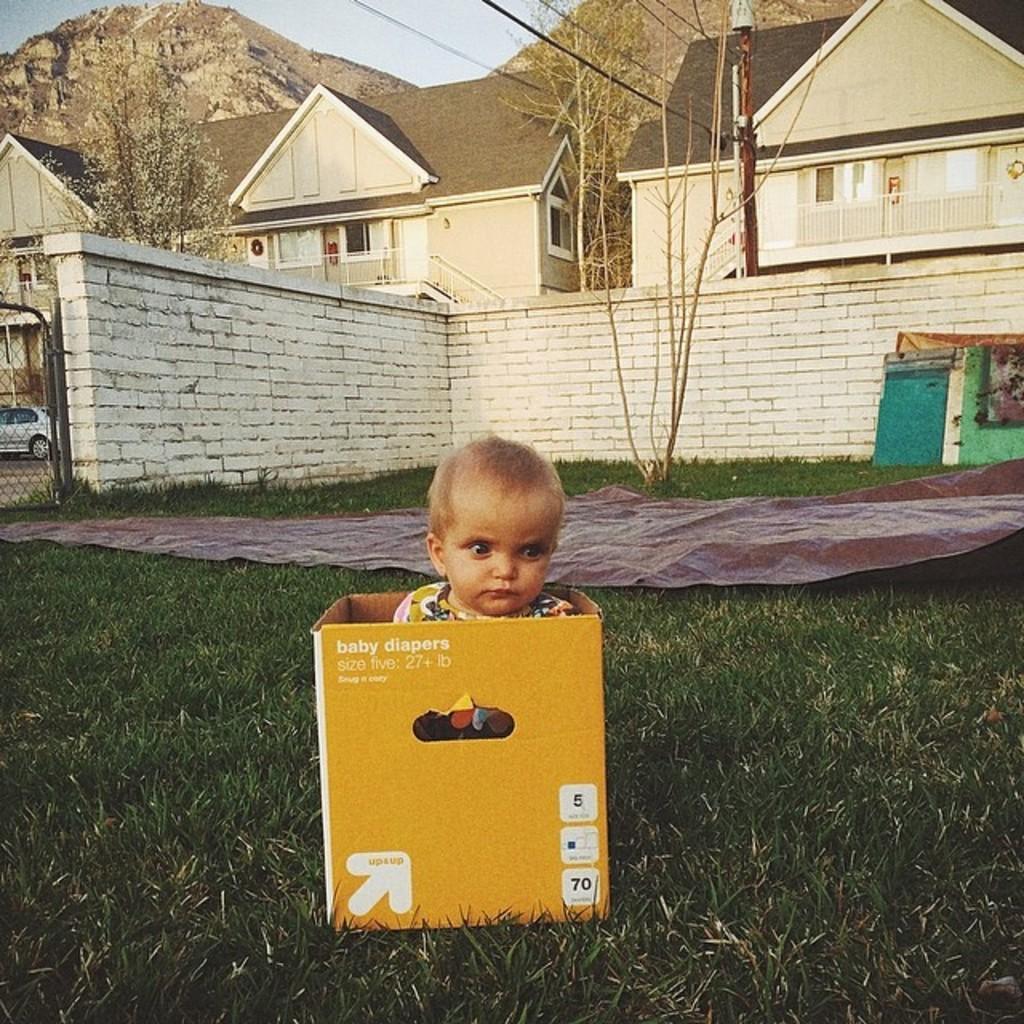In one or two sentences, can you explain what this image depicts? In the image there is a grass in the foreground and there is a box, inside the box there is a baby, behind the grass surface there is a wall and behind the wall there are houses, trees and mountains. 